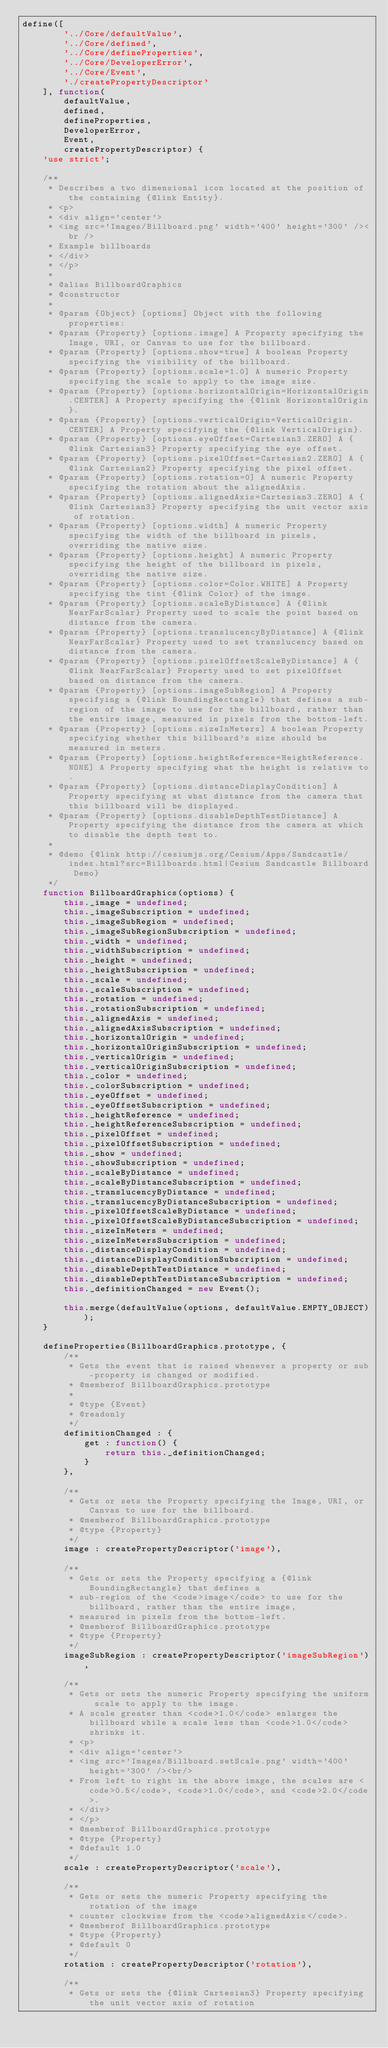<code> <loc_0><loc_0><loc_500><loc_500><_JavaScript_>define([
        '../Core/defaultValue',
        '../Core/defined',
        '../Core/defineProperties',
        '../Core/DeveloperError',
        '../Core/Event',
        './createPropertyDescriptor'
    ], function(
        defaultValue,
        defined,
        defineProperties,
        DeveloperError,
        Event,
        createPropertyDescriptor) {
    'use strict';

    /**
     * Describes a two dimensional icon located at the position of the containing {@link Entity}.
     * <p>
     * <div align='center'>
     * <img src='Images/Billboard.png' width='400' height='300' /><br />
     * Example billboards
     * </div>
     * </p>
     *
     * @alias BillboardGraphics
     * @constructor
     *
     * @param {Object} [options] Object with the following properties:
     * @param {Property} [options.image] A Property specifying the Image, URI, or Canvas to use for the billboard.
     * @param {Property} [options.show=true] A boolean Property specifying the visibility of the billboard.
     * @param {Property} [options.scale=1.0] A numeric Property specifying the scale to apply to the image size.
     * @param {Property} [options.horizontalOrigin=HorizontalOrigin.CENTER] A Property specifying the {@link HorizontalOrigin}.
     * @param {Property} [options.verticalOrigin=VerticalOrigin.CENTER] A Property specifying the {@link VerticalOrigin}.
     * @param {Property} [options.eyeOffset=Cartesian3.ZERO] A {@link Cartesian3} Property specifying the eye offset.
     * @param {Property} [options.pixelOffset=Cartesian2.ZERO] A {@link Cartesian2} Property specifying the pixel offset.
     * @param {Property} [options.rotation=0] A numeric Property specifying the rotation about the alignedAxis.
     * @param {Property} [options.alignedAxis=Cartesian3.ZERO] A {@link Cartesian3} Property specifying the unit vector axis of rotation.
     * @param {Property} [options.width] A numeric Property specifying the width of the billboard in pixels, overriding the native size.
     * @param {Property} [options.height] A numeric Property specifying the height of the billboard in pixels, overriding the native size.
     * @param {Property} [options.color=Color.WHITE] A Property specifying the tint {@link Color} of the image.
     * @param {Property} [options.scaleByDistance] A {@link NearFarScalar} Property used to scale the point based on distance from the camera.
     * @param {Property} [options.translucencyByDistance] A {@link NearFarScalar} Property used to set translucency based on distance from the camera.
     * @param {Property} [options.pixelOffsetScaleByDistance] A {@link NearFarScalar} Property used to set pixelOffset based on distance from the camera.
     * @param {Property} [options.imageSubRegion] A Property specifying a {@link BoundingRectangle} that defines a sub-region of the image to use for the billboard, rather than the entire image, measured in pixels from the bottom-left.
     * @param {Property} [options.sizeInMeters] A boolean Property specifying whether this billboard's size should be measured in meters.
     * @param {Property} [options.heightReference=HeightReference.NONE] A Property specifying what the height is relative to.
     * @param {Property} [options.distanceDisplayCondition] A Property specifying at what distance from the camera that this billboard will be displayed.
     * @param {Property} [options.disableDepthTestDistance] A Property specifying the distance from the camera at which to disable the depth test to.
     *
     * @demo {@link http://cesiumjs.org/Cesium/Apps/Sandcastle/index.html?src=Billboards.html|Cesium Sandcastle Billboard Demo}
     */
    function BillboardGraphics(options) {
        this._image = undefined;
        this._imageSubscription = undefined;
        this._imageSubRegion = undefined;
        this._imageSubRegionSubscription = undefined;
        this._width = undefined;
        this._widthSubscription = undefined;
        this._height = undefined;
        this._heightSubscription = undefined;
        this._scale = undefined;
        this._scaleSubscription = undefined;
        this._rotation = undefined;
        this._rotationSubscription = undefined;
        this._alignedAxis = undefined;
        this._alignedAxisSubscription = undefined;
        this._horizontalOrigin = undefined;
        this._horizontalOriginSubscription = undefined;
        this._verticalOrigin = undefined;
        this._verticalOriginSubscription = undefined;
        this._color = undefined;
        this._colorSubscription = undefined;
        this._eyeOffset = undefined;
        this._eyeOffsetSubscription = undefined;
        this._heightReference = undefined;
        this._heightReferenceSubscription = undefined;
        this._pixelOffset = undefined;
        this._pixelOffsetSubscription = undefined;
        this._show = undefined;
        this._showSubscription = undefined;
        this._scaleByDistance = undefined;
        this._scaleByDistanceSubscription = undefined;
        this._translucencyByDistance = undefined;
        this._translucencyByDistanceSubscription = undefined;
        this._pixelOffsetScaleByDistance = undefined;
        this._pixelOffsetScaleByDistanceSubscription = undefined;
        this._sizeInMeters = undefined;
        this._sizeInMetersSubscription = undefined;
        this._distanceDisplayCondition = undefined;
        this._distanceDisplayConditionSubscription = undefined;
        this._disableDepthTestDistance = undefined;
        this._disableDepthTestDistanceSubscription = undefined;
        this._definitionChanged = new Event();

        this.merge(defaultValue(options, defaultValue.EMPTY_OBJECT));
    }

    defineProperties(BillboardGraphics.prototype, {
        /**
         * Gets the event that is raised whenever a property or sub-property is changed or modified.
         * @memberof BillboardGraphics.prototype
         *
         * @type {Event}
         * @readonly
         */
        definitionChanged : {
            get : function() {
                return this._definitionChanged;
            }
        },

        /**
         * Gets or sets the Property specifying the Image, URI, or Canvas to use for the billboard.
         * @memberof BillboardGraphics.prototype
         * @type {Property}
         */
        image : createPropertyDescriptor('image'),

        /**
         * Gets or sets the Property specifying a {@link BoundingRectangle} that defines a
         * sub-region of the <code>image</code> to use for the billboard, rather than the entire image,
         * measured in pixels from the bottom-left.
         * @memberof BillboardGraphics.prototype
         * @type {Property}
         */
        imageSubRegion : createPropertyDescriptor('imageSubRegion'),

        /**
         * Gets or sets the numeric Property specifying the uniform scale to apply to the image.
         * A scale greater than <code>1.0</code> enlarges the billboard while a scale less than <code>1.0</code> shrinks it.
         * <p>
         * <div align='center'>
         * <img src='Images/Billboard.setScale.png' width='400' height='300' /><br/>
         * From left to right in the above image, the scales are <code>0.5</code>, <code>1.0</code>, and <code>2.0</code>.
         * </div>
         * </p>
         * @memberof BillboardGraphics.prototype
         * @type {Property}
         * @default 1.0
         */
        scale : createPropertyDescriptor('scale'),

        /**
         * Gets or sets the numeric Property specifying the rotation of the image
         * counter clockwise from the <code>alignedAxis</code>.
         * @memberof BillboardGraphics.prototype
         * @type {Property}
         * @default 0
         */
        rotation : createPropertyDescriptor('rotation'),

        /**
         * Gets or sets the {@link Cartesian3} Property specifying the unit vector axis of rotation</code> 